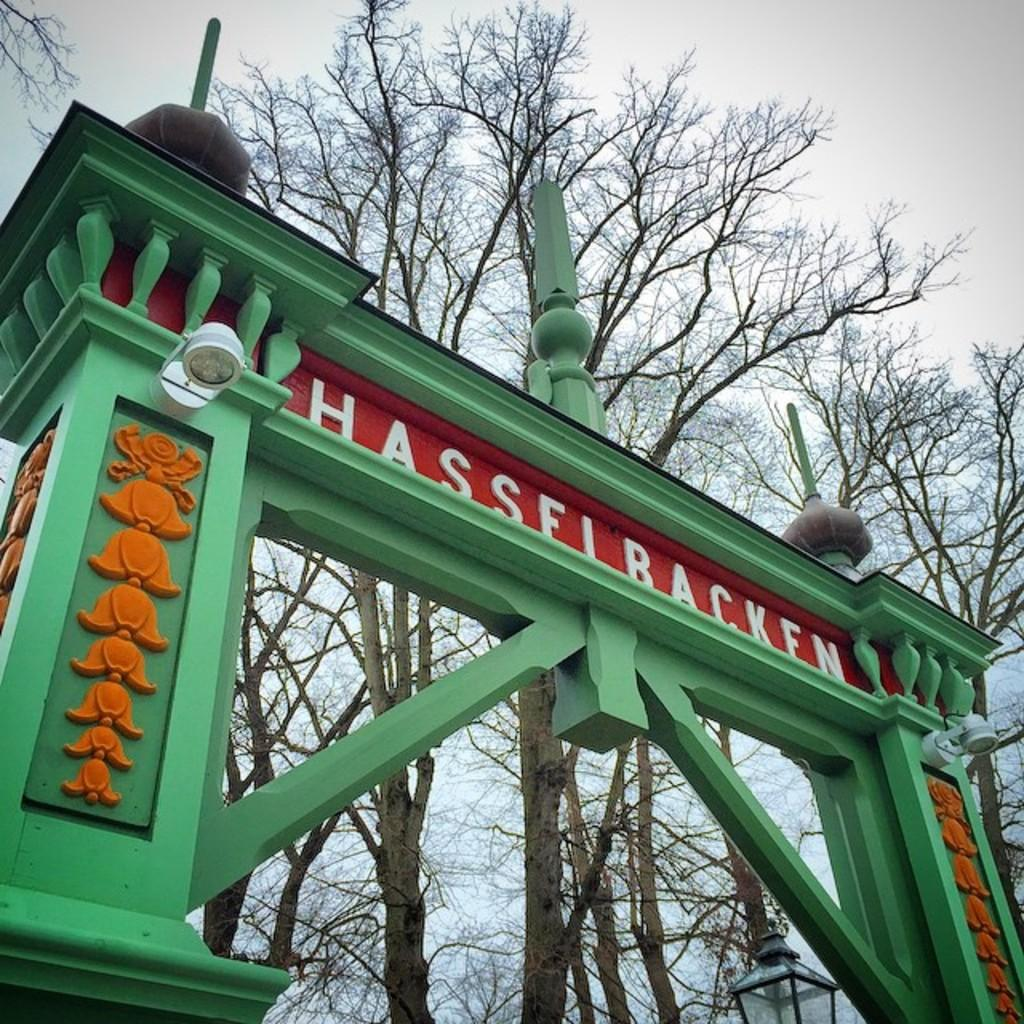What type of structure is present in the picture? There is an arch in the picture. What is the color of the arch? The arch is green in color. What can be seen in the background of the picture? There are trees in the background of the picture. What is visible at the top of the picture? The sky is visible at the top of the picture. What is the condition of the sky in the picture? The sky is clear in the picture. What time of day is it in the image, and is the fire burning in the morning? The time of day is not mentioned in the image, and there is no fire present to determine if it is burning in the morning. 